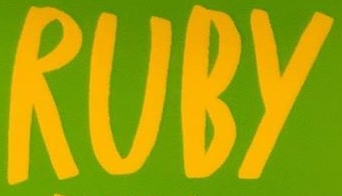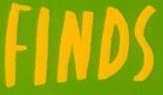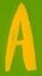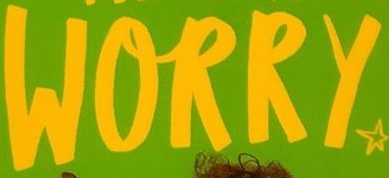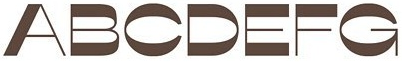Identify the words shown in these images in order, separated by a semicolon. RUBY; FINDS; A; WORRY; ABCDEFG 